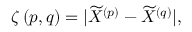<formula> <loc_0><loc_0><loc_500><loc_500>\begin{array} { r } { \zeta \left ( p , q \right ) = | \widetilde { X } ^ { \left ( p \right ) } - \widetilde { X } ^ { \left ( q \right ) } | , } \end{array}</formula> 